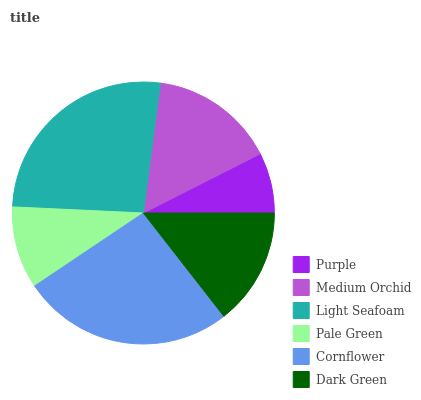Is Purple the minimum?
Answer yes or no. Yes. Is Light Seafoam the maximum?
Answer yes or no. Yes. Is Medium Orchid the minimum?
Answer yes or no. No. Is Medium Orchid the maximum?
Answer yes or no. No. Is Medium Orchid greater than Purple?
Answer yes or no. Yes. Is Purple less than Medium Orchid?
Answer yes or no. Yes. Is Purple greater than Medium Orchid?
Answer yes or no. No. Is Medium Orchid less than Purple?
Answer yes or no. No. Is Medium Orchid the high median?
Answer yes or no. Yes. Is Dark Green the low median?
Answer yes or no. Yes. Is Pale Green the high median?
Answer yes or no. No. Is Cornflower the low median?
Answer yes or no. No. 